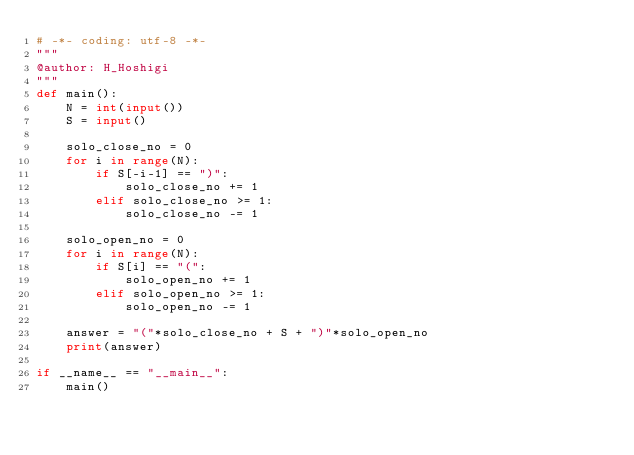Convert code to text. <code><loc_0><loc_0><loc_500><loc_500><_Python_># -*- coding: utf-8 -*-
"""
@author: H_Hoshigi
"""
def main():
    N = int(input())
    S = input()

    solo_close_no = 0
    for i in range(N):
        if S[-i-1] == ")":
            solo_close_no += 1
        elif solo_close_no >= 1:
            solo_close_no -= 1
    
    solo_open_no = 0
    for i in range(N):
        if S[i] == "(":
            solo_open_no += 1
        elif solo_open_no >= 1:
            solo_open_no -= 1

    answer = "("*solo_close_no + S + ")"*solo_open_no
    print(answer)

if __name__ == "__main__":
    main()

</code> 